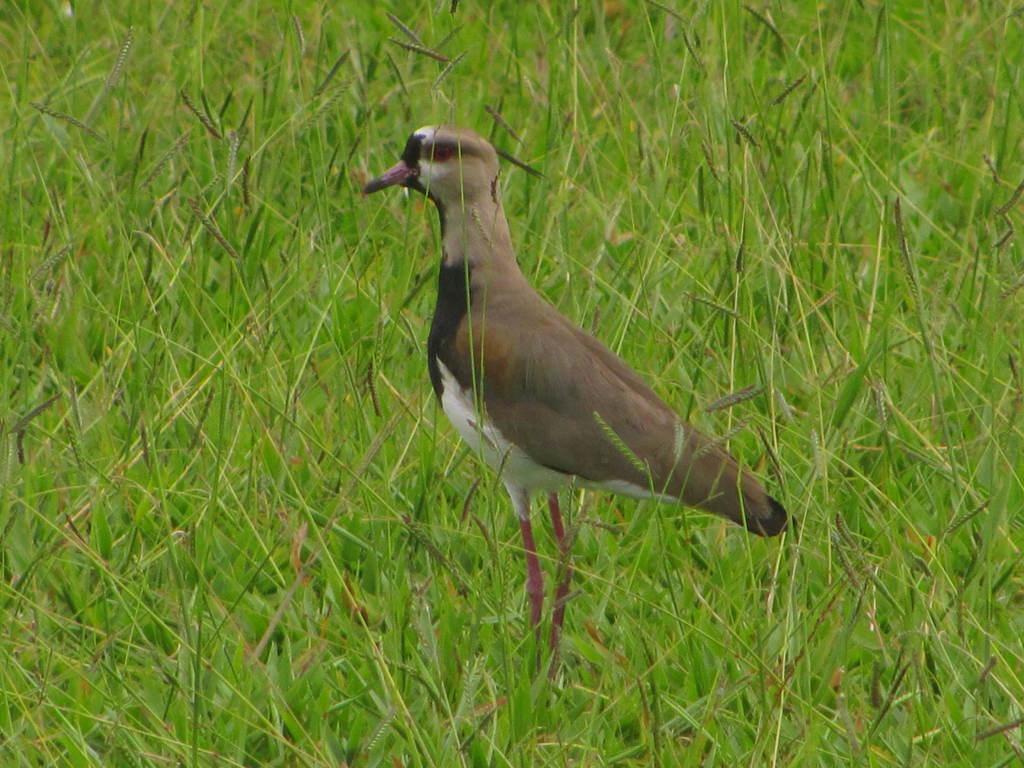Please provide a concise description of this image. In this image there is a killdeer bird standing on the grass. 